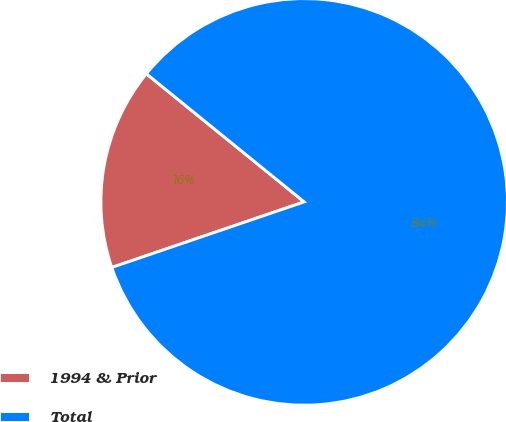Convert chart to OTSL. <chart><loc_0><loc_0><loc_500><loc_500><pie_chart><fcel>1994 & Prior<fcel>Total<nl><fcel>16.08%<fcel>83.92%<nl></chart> 